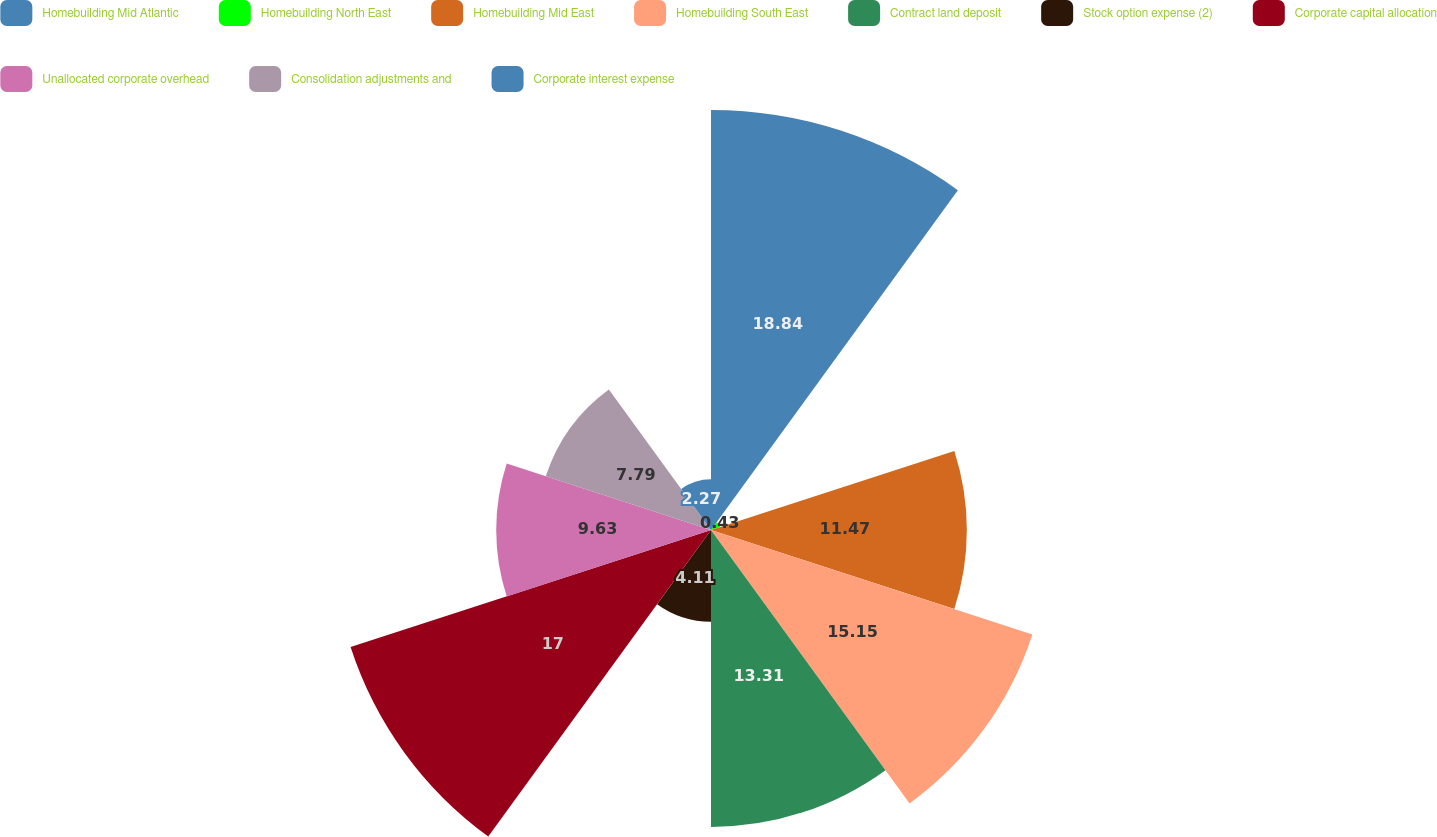<chart> <loc_0><loc_0><loc_500><loc_500><pie_chart><fcel>Homebuilding Mid Atlantic<fcel>Homebuilding North East<fcel>Homebuilding Mid East<fcel>Homebuilding South East<fcel>Contract land deposit<fcel>Stock option expense (2)<fcel>Corporate capital allocation<fcel>Unallocated corporate overhead<fcel>Consolidation adjustments and<fcel>Corporate interest expense<nl><fcel>18.83%<fcel>0.43%<fcel>11.47%<fcel>15.15%<fcel>13.31%<fcel>4.11%<fcel>16.99%<fcel>9.63%<fcel>7.79%<fcel>2.27%<nl></chart> 